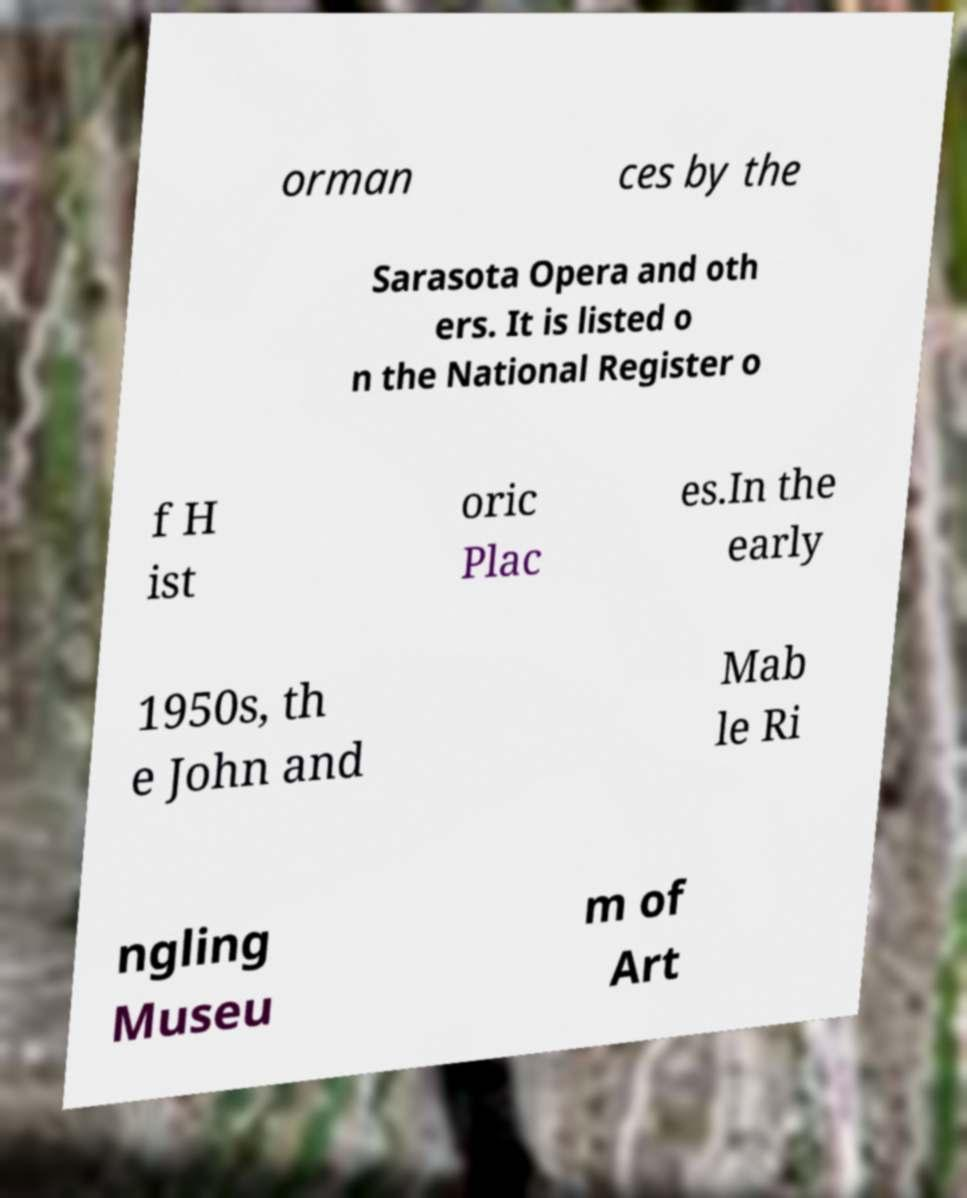For documentation purposes, I need the text within this image transcribed. Could you provide that? orman ces by the Sarasota Opera and oth ers. It is listed o n the National Register o f H ist oric Plac es.In the early 1950s, th e John and Mab le Ri ngling Museu m of Art 